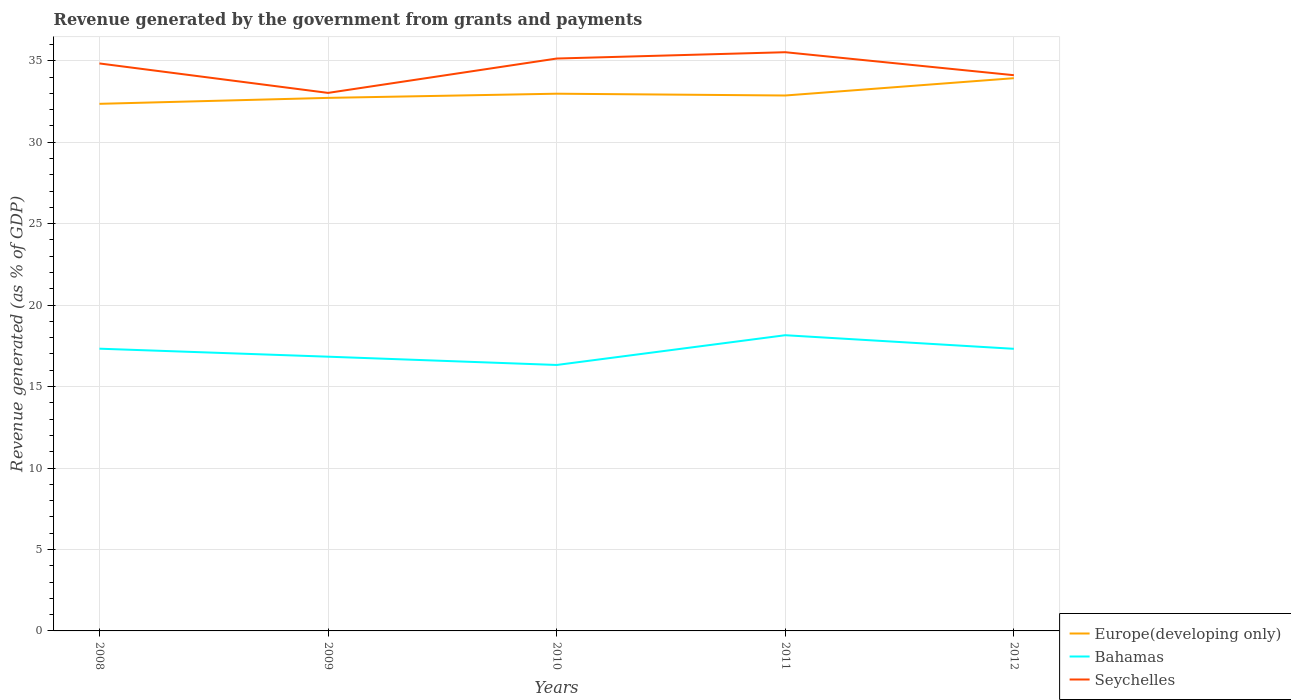Is the number of lines equal to the number of legend labels?
Provide a succinct answer. Yes. Across all years, what is the maximum revenue generated by the government in Europe(developing only)?
Your response must be concise. 32.35. What is the total revenue generated by the government in Seychelles in the graph?
Offer a terse response. 1.81. What is the difference between the highest and the second highest revenue generated by the government in Seychelles?
Your response must be concise. 2.5. What is the difference between the highest and the lowest revenue generated by the government in Bahamas?
Your answer should be compact. 3. Is the revenue generated by the government in Seychelles strictly greater than the revenue generated by the government in Bahamas over the years?
Provide a short and direct response. No. How many lines are there?
Your answer should be compact. 3. How many years are there in the graph?
Make the answer very short. 5. What is the difference between two consecutive major ticks on the Y-axis?
Offer a terse response. 5. Are the values on the major ticks of Y-axis written in scientific E-notation?
Your answer should be very brief. No. Where does the legend appear in the graph?
Ensure brevity in your answer.  Bottom right. How are the legend labels stacked?
Keep it short and to the point. Vertical. What is the title of the graph?
Offer a terse response. Revenue generated by the government from grants and payments. What is the label or title of the Y-axis?
Give a very brief answer. Revenue generated (as % of GDP). What is the Revenue generated (as % of GDP) in Europe(developing only) in 2008?
Provide a short and direct response. 32.35. What is the Revenue generated (as % of GDP) in Bahamas in 2008?
Your answer should be very brief. 17.32. What is the Revenue generated (as % of GDP) in Seychelles in 2008?
Offer a terse response. 34.83. What is the Revenue generated (as % of GDP) of Europe(developing only) in 2009?
Your answer should be compact. 32.72. What is the Revenue generated (as % of GDP) in Bahamas in 2009?
Provide a short and direct response. 16.83. What is the Revenue generated (as % of GDP) of Seychelles in 2009?
Offer a very short reply. 33.03. What is the Revenue generated (as % of GDP) of Europe(developing only) in 2010?
Keep it short and to the point. 32.98. What is the Revenue generated (as % of GDP) of Bahamas in 2010?
Offer a very short reply. 16.32. What is the Revenue generated (as % of GDP) of Seychelles in 2010?
Ensure brevity in your answer.  35.13. What is the Revenue generated (as % of GDP) of Europe(developing only) in 2011?
Offer a very short reply. 32.87. What is the Revenue generated (as % of GDP) of Bahamas in 2011?
Your answer should be very brief. 18.15. What is the Revenue generated (as % of GDP) in Seychelles in 2011?
Provide a short and direct response. 35.52. What is the Revenue generated (as % of GDP) in Europe(developing only) in 2012?
Your answer should be very brief. 33.93. What is the Revenue generated (as % of GDP) in Bahamas in 2012?
Offer a terse response. 17.32. What is the Revenue generated (as % of GDP) in Seychelles in 2012?
Your answer should be very brief. 34.11. Across all years, what is the maximum Revenue generated (as % of GDP) of Europe(developing only)?
Offer a very short reply. 33.93. Across all years, what is the maximum Revenue generated (as % of GDP) in Bahamas?
Give a very brief answer. 18.15. Across all years, what is the maximum Revenue generated (as % of GDP) in Seychelles?
Provide a short and direct response. 35.52. Across all years, what is the minimum Revenue generated (as % of GDP) of Europe(developing only)?
Keep it short and to the point. 32.35. Across all years, what is the minimum Revenue generated (as % of GDP) of Bahamas?
Offer a terse response. 16.32. Across all years, what is the minimum Revenue generated (as % of GDP) of Seychelles?
Provide a short and direct response. 33.03. What is the total Revenue generated (as % of GDP) of Europe(developing only) in the graph?
Provide a succinct answer. 164.85. What is the total Revenue generated (as % of GDP) of Bahamas in the graph?
Keep it short and to the point. 85.95. What is the total Revenue generated (as % of GDP) of Seychelles in the graph?
Your response must be concise. 172.63. What is the difference between the Revenue generated (as % of GDP) in Europe(developing only) in 2008 and that in 2009?
Your answer should be very brief. -0.37. What is the difference between the Revenue generated (as % of GDP) in Bahamas in 2008 and that in 2009?
Keep it short and to the point. 0.49. What is the difference between the Revenue generated (as % of GDP) of Seychelles in 2008 and that in 2009?
Offer a very short reply. 1.81. What is the difference between the Revenue generated (as % of GDP) in Europe(developing only) in 2008 and that in 2010?
Provide a short and direct response. -0.62. What is the difference between the Revenue generated (as % of GDP) of Bahamas in 2008 and that in 2010?
Provide a succinct answer. 1. What is the difference between the Revenue generated (as % of GDP) of Seychelles in 2008 and that in 2010?
Offer a terse response. -0.3. What is the difference between the Revenue generated (as % of GDP) of Europe(developing only) in 2008 and that in 2011?
Your answer should be compact. -0.51. What is the difference between the Revenue generated (as % of GDP) in Bahamas in 2008 and that in 2011?
Provide a short and direct response. -0.83. What is the difference between the Revenue generated (as % of GDP) of Seychelles in 2008 and that in 2011?
Offer a very short reply. -0.69. What is the difference between the Revenue generated (as % of GDP) in Europe(developing only) in 2008 and that in 2012?
Offer a very short reply. -1.57. What is the difference between the Revenue generated (as % of GDP) in Bahamas in 2008 and that in 2012?
Your response must be concise. 0.01. What is the difference between the Revenue generated (as % of GDP) of Seychelles in 2008 and that in 2012?
Keep it short and to the point. 0.72. What is the difference between the Revenue generated (as % of GDP) of Europe(developing only) in 2009 and that in 2010?
Provide a succinct answer. -0.26. What is the difference between the Revenue generated (as % of GDP) of Bahamas in 2009 and that in 2010?
Your response must be concise. 0.51. What is the difference between the Revenue generated (as % of GDP) in Seychelles in 2009 and that in 2010?
Your response must be concise. -2.11. What is the difference between the Revenue generated (as % of GDP) of Europe(developing only) in 2009 and that in 2011?
Your answer should be compact. -0.15. What is the difference between the Revenue generated (as % of GDP) in Bahamas in 2009 and that in 2011?
Your answer should be compact. -1.32. What is the difference between the Revenue generated (as % of GDP) in Seychelles in 2009 and that in 2011?
Make the answer very short. -2.5. What is the difference between the Revenue generated (as % of GDP) in Europe(developing only) in 2009 and that in 2012?
Give a very brief answer. -1.21. What is the difference between the Revenue generated (as % of GDP) in Bahamas in 2009 and that in 2012?
Make the answer very short. -0.48. What is the difference between the Revenue generated (as % of GDP) of Seychelles in 2009 and that in 2012?
Offer a terse response. -1.09. What is the difference between the Revenue generated (as % of GDP) of Europe(developing only) in 2010 and that in 2011?
Offer a terse response. 0.11. What is the difference between the Revenue generated (as % of GDP) of Bahamas in 2010 and that in 2011?
Give a very brief answer. -1.83. What is the difference between the Revenue generated (as % of GDP) of Seychelles in 2010 and that in 2011?
Make the answer very short. -0.39. What is the difference between the Revenue generated (as % of GDP) in Europe(developing only) in 2010 and that in 2012?
Your answer should be compact. -0.95. What is the difference between the Revenue generated (as % of GDP) of Bahamas in 2010 and that in 2012?
Ensure brevity in your answer.  -0.99. What is the difference between the Revenue generated (as % of GDP) of Seychelles in 2010 and that in 2012?
Keep it short and to the point. 1.02. What is the difference between the Revenue generated (as % of GDP) of Europe(developing only) in 2011 and that in 2012?
Ensure brevity in your answer.  -1.06. What is the difference between the Revenue generated (as % of GDP) of Bahamas in 2011 and that in 2012?
Offer a terse response. 0.83. What is the difference between the Revenue generated (as % of GDP) of Seychelles in 2011 and that in 2012?
Offer a very short reply. 1.41. What is the difference between the Revenue generated (as % of GDP) of Europe(developing only) in 2008 and the Revenue generated (as % of GDP) of Bahamas in 2009?
Provide a succinct answer. 15.52. What is the difference between the Revenue generated (as % of GDP) in Europe(developing only) in 2008 and the Revenue generated (as % of GDP) in Seychelles in 2009?
Your response must be concise. -0.67. What is the difference between the Revenue generated (as % of GDP) in Bahamas in 2008 and the Revenue generated (as % of GDP) in Seychelles in 2009?
Keep it short and to the point. -15.7. What is the difference between the Revenue generated (as % of GDP) of Europe(developing only) in 2008 and the Revenue generated (as % of GDP) of Bahamas in 2010?
Offer a terse response. 16.03. What is the difference between the Revenue generated (as % of GDP) of Europe(developing only) in 2008 and the Revenue generated (as % of GDP) of Seychelles in 2010?
Ensure brevity in your answer.  -2.78. What is the difference between the Revenue generated (as % of GDP) in Bahamas in 2008 and the Revenue generated (as % of GDP) in Seychelles in 2010?
Provide a succinct answer. -17.81. What is the difference between the Revenue generated (as % of GDP) of Europe(developing only) in 2008 and the Revenue generated (as % of GDP) of Bahamas in 2011?
Ensure brevity in your answer.  14.2. What is the difference between the Revenue generated (as % of GDP) of Europe(developing only) in 2008 and the Revenue generated (as % of GDP) of Seychelles in 2011?
Offer a terse response. -3.17. What is the difference between the Revenue generated (as % of GDP) in Bahamas in 2008 and the Revenue generated (as % of GDP) in Seychelles in 2011?
Provide a short and direct response. -18.2. What is the difference between the Revenue generated (as % of GDP) in Europe(developing only) in 2008 and the Revenue generated (as % of GDP) in Bahamas in 2012?
Your answer should be very brief. 15.04. What is the difference between the Revenue generated (as % of GDP) of Europe(developing only) in 2008 and the Revenue generated (as % of GDP) of Seychelles in 2012?
Keep it short and to the point. -1.76. What is the difference between the Revenue generated (as % of GDP) of Bahamas in 2008 and the Revenue generated (as % of GDP) of Seychelles in 2012?
Provide a short and direct response. -16.79. What is the difference between the Revenue generated (as % of GDP) in Europe(developing only) in 2009 and the Revenue generated (as % of GDP) in Bahamas in 2010?
Keep it short and to the point. 16.4. What is the difference between the Revenue generated (as % of GDP) of Europe(developing only) in 2009 and the Revenue generated (as % of GDP) of Seychelles in 2010?
Offer a very short reply. -2.41. What is the difference between the Revenue generated (as % of GDP) of Bahamas in 2009 and the Revenue generated (as % of GDP) of Seychelles in 2010?
Your answer should be very brief. -18.3. What is the difference between the Revenue generated (as % of GDP) of Europe(developing only) in 2009 and the Revenue generated (as % of GDP) of Bahamas in 2011?
Keep it short and to the point. 14.57. What is the difference between the Revenue generated (as % of GDP) of Europe(developing only) in 2009 and the Revenue generated (as % of GDP) of Seychelles in 2011?
Make the answer very short. -2.8. What is the difference between the Revenue generated (as % of GDP) of Bahamas in 2009 and the Revenue generated (as % of GDP) of Seychelles in 2011?
Your answer should be very brief. -18.69. What is the difference between the Revenue generated (as % of GDP) in Europe(developing only) in 2009 and the Revenue generated (as % of GDP) in Bahamas in 2012?
Your answer should be compact. 15.4. What is the difference between the Revenue generated (as % of GDP) of Europe(developing only) in 2009 and the Revenue generated (as % of GDP) of Seychelles in 2012?
Your answer should be compact. -1.39. What is the difference between the Revenue generated (as % of GDP) of Bahamas in 2009 and the Revenue generated (as % of GDP) of Seychelles in 2012?
Your answer should be compact. -17.28. What is the difference between the Revenue generated (as % of GDP) of Europe(developing only) in 2010 and the Revenue generated (as % of GDP) of Bahamas in 2011?
Make the answer very short. 14.82. What is the difference between the Revenue generated (as % of GDP) of Europe(developing only) in 2010 and the Revenue generated (as % of GDP) of Seychelles in 2011?
Provide a short and direct response. -2.55. What is the difference between the Revenue generated (as % of GDP) of Bahamas in 2010 and the Revenue generated (as % of GDP) of Seychelles in 2011?
Offer a very short reply. -19.2. What is the difference between the Revenue generated (as % of GDP) of Europe(developing only) in 2010 and the Revenue generated (as % of GDP) of Bahamas in 2012?
Ensure brevity in your answer.  15.66. What is the difference between the Revenue generated (as % of GDP) in Europe(developing only) in 2010 and the Revenue generated (as % of GDP) in Seychelles in 2012?
Offer a terse response. -1.14. What is the difference between the Revenue generated (as % of GDP) in Bahamas in 2010 and the Revenue generated (as % of GDP) in Seychelles in 2012?
Make the answer very short. -17.79. What is the difference between the Revenue generated (as % of GDP) of Europe(developing only) in 2011 and the Revenue generated (as % of GDP) of Bahamas in 2012?
Provide a short and direct response. 15.55. What is the difference between the Revenue generated (as % of GDP) in Europe(developing only) in 2011 and the Revenue generated (as % of GDP) in Seychelles in 2012?
Your answer should be very brief. -1.25. What is the difference between the Revenue generated (as % of GDP) in Bahamas in 2011 and the Revenue generated (as % of GDP) in Seychelles in 2012?
Your answer should be very brief. -15.96. What is the average Revenue generated (as % of GDP) of Europe(developing only) per year?
Offer a terse response. 32.97. What is the average Revenue generated (as % of GDP) in Bahamas per year?
Offer a terse response. 17.19. What is the average Revenue generated (as % of GDP) in Seychelles per year?
Make the answer very short. 34.53. In the year 2008, what is the difference between the Revenue generated (as % of GDP) in Europe(developing only) and Revenue generated (as % of GDP) in Bahamas?
Your response must be concise. 15.03. In the year 2008, what is the difference between the Revenue generated (as % of GDP) in Europe(developing only) and Revenue generated (as % of GDP) in Seychelles?
Your answer should be very brief. -2.48. In the year 2008, what is the difference between the Revenue generated (as % of GDP) of Bahamas and Revenue generated (as % of GDP) of Seychelles?
Offer a terse response. -17.51. In the year 2009, what is the difference between the Revenue generated (as % of GDP) of Europe(developing only) and Revenue generated (as % of GDP) of Bahamas?
Keep it short and to the point. 15.89. In the year 2009, what is the difference between the Revenue generated (as % of GDP) in Europe(developing only) and Revenue generated (as % of GDP) in Seychelles?
Offer a terse response. -0.31. In the year 2009, what is the difference between the Revenue generated (as % of GDP) in Bahamas and Revenue generated (as % of GDP) in Seychelles?
Your response must be concise. -16.19. In the year 2010, what is the difference between the Revenue generated (as % of GDP) of Europe(developing only) and Revenue generated (as % of GDP) of Bahamas?
Offer a terse response. 16.65. In the year 2010, what is the difference between the Revenue generated (as % of GDP) in Europe(developing only) and Revenue generated (as % of GDP) in Seychelles?
Offer a very short reply. -2.16. In the year 2010, what is the difference between the Revenue generated (as % of GDP) in Bahamas and Revenue generated (as % of GDP) in Seychelles?
Your answer should be compact. -18.81. In the year 2011, what is the difference between the Revenue generated (as % of GDP) of Europe(developing only) and Revenue generated (as % of GDP) of Bahamas?
Make the answer very short. 14.71. In the year 2011, what is the difference between the Revenue generated (as % of GDP) in Europe(developing only) and Revenue generated (as % of GDP) in Seychelles?
Give a very brief answer. -2.66. In the year 2011, what is the difference between the Revenue generated (as % of GDP) of Bahamas and Revenue generated (as % of GDP) of Seychelles?
Ensure brevity in your answer.  -17.37. In the year 2012, what is the difference between the Revenue generated (as % of GDP) in Europe(developing only) and Revenue generated (as % of GDP) in Bahamas?
Your response must be concise. 16.61. In the year 2012, what is the difference between the Revenue generated (as % of GDP) in Europe(developing only) and Revenue generated (as % of GDP) in Seychelles?
Make the answer very short. -0.18. In the year 2012, what is the difference between the Revenue generated (as % of GDP) in Bahamas and Revenue generated (as % of GDP) in Seychelles?
Make the answer very short. -16.8. What is the ratio of the Revenue generated (as % of GDP) of Europe(developing only) in 2008 to that in 2009?
Ensure brevity in your answer.  0.99. What is the ratio of the Revenue generated (as % of GDP) of Bahamas in 2008 to that in 2009?
Your response must be concise. 1.03. What is the ratio of the Revenue generated (as % of GDP) of Seychelles in 2008 to that in 2009?
Offer a very short reply. 1.05. What is the ratio of the Revenue generated (as % of GDP) in Europe(developing only) in 2008 to that in 2010?
Offer a very short reply. 0.98. What is the ratio of the Revenue generated (as % of GDP) in Bahamas in 2008 to that in 2010?
Give a very brief answer. 1.06. What is the ratio of the Revenue generated (as % of GDP) of Europe(developing only) in 2008 to that in 2011?
Offer a terse response. 0.98. What is the ratio of the Revenue generated (as % of GDP) of Bahamas in 2008 to that in 2011?
Ensure brevity in your answer.  0.95. What is the ratio of the Revenue generated (as % of GDP) in Seychelles in 2008 to that in 2011?
Ensure brevity in your answer.  0.98. What is the ratio of the Revenue generated (as % of GDP) of Europe(developing only) in 2008 to that in 2012?
Your answer should be compact. 0.95. What is the ratio of the Revenue generated (as % of GDP) of Bahamas in 2008 to that in 2012?
Offer a very short reply. 1. What is the ratio of the Revenue generated (as % of GDP) of Seychelles in 2008 to that in 2012?
Provide a succinct answer. 1.02. What is the ratio of the Revenue generated (as % of GDP) in Bahamas in 2009 to that in 2010?
Give a very brief answer. 1.03. What is the ratio of the Revenue generated (as % of GDP) in Seychelles in 2009 to that in 2010?
Provide a short and direct response. 0.94. What is the ratio of the Revenue generated (as % of GDP) in Bahamas in 2009 to that in 2011?
Keep it short and to the point. 0.93. What is the ratio of the Revenue generated (as % of GDP) of Seychelles in 2009 to that in 2011?
Make the answer very short. 0.93. What is the ratio of the Revenue generated (as % of GDP) in Europe(developing only) in 2009 to that in 2012?
Offer a terse response. 0.96. What is the ratio of the Revenue generated (as % of GDP) of Bahamas in 2009 to that in 2012?
Offer a terse response. 0.97. What is the ratio of the Revenue generated (as % of GDP) in Seychelles in 2009 to that in 2012?
Ensure brevity in your answer.  0.97. What is the ratio of the Revenue generated (as % of GDP) in Europe(developing only) in 2010 to that in 2011?
Make the answer very short. 1. What is the ratio of the Revenue generated (as % of GDP) of Bahamas in 2010 to that in 2011?
Keep it short and to the point. 0.9. What is the ratio of the Revenue generated (as % of GDP) of Seychelles in 2010 to that in 2011?
Give a very brief answer. 0.99. What is the ratio of the Revenue generated (as % of GDP) in Europe(developing only) in 2010 to that in 2012?
Make the answer very short. 0.97. What is the ratio of the Revenue generated (as % of GDP) of Bahamas in 2010 to that in 2012?
Provide a short and direct response. 0.94. What is the ratio of the Revenue generated (as % of GDP) in Europe(developing only) in 2011 to that in 2012?
Your response must be concise. 0.97. What is the ratio of the Revenue generated (as % of GDP) of Bahamas in 2011 to that in 2012?
Your answer should be compact. 1.05. What is the ratio of the Revenue generated (as % of GDP) of Seychelles in 2011 to that in 2012?
Provide a short and direct response. 1.04. What is the difference between the highest and the second highest Revenue generated (as % of GDP) in Europe(developing only)?
Make the answer very short. 0.95. What is the difference between the highest and the second highest Revenue generated (as % of GDP) of Bahamas?
Make the answer very short. 0.83. What is the difference between the highest and the second highest Revenue generated (as % of GDP) of Seychelles?
Offer a very short reply. 0.39. What is the difference between the highest and the lowest Revenue generated (as % of GDP) of Europe(developing only)?
Make the answer very short. 1.57. What is the difference between the highest and the lowest Revenue generated (as % of GDP) in Bahamas?
Your answer should be compact. 1.83. What is the difference between the highest and the lowest Revenue generated (as % of GDP) in Seychelles?
Offer a terse response. 2.5. 